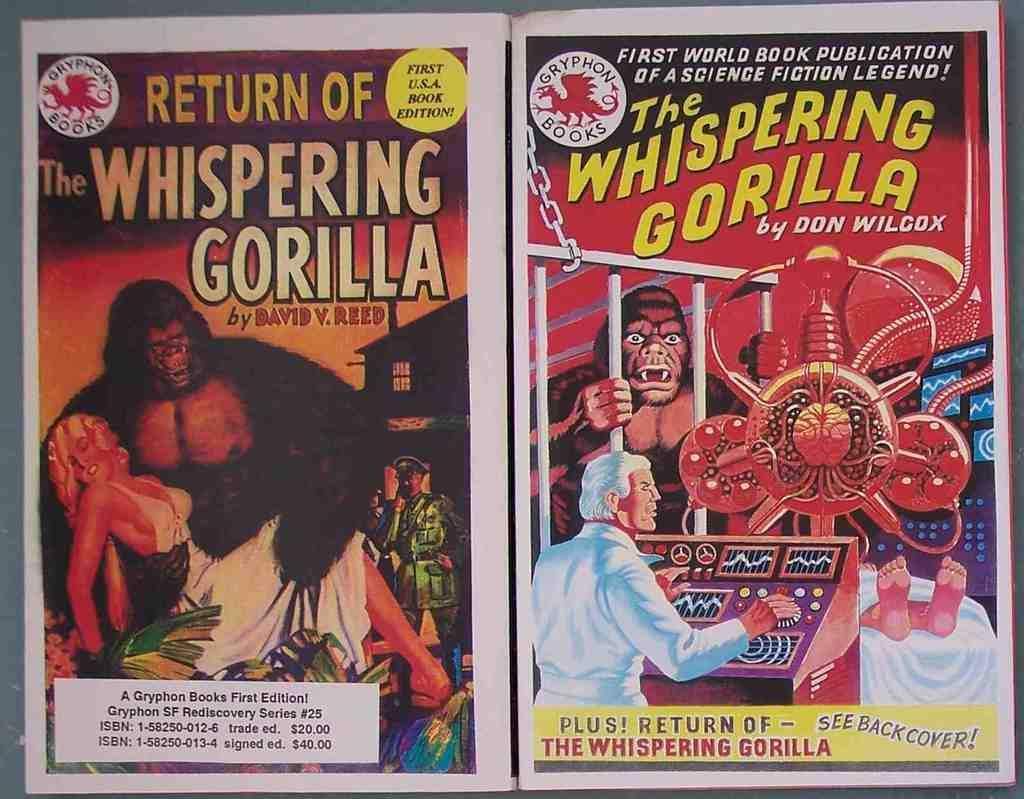Please provide a concise description of this image. As we can see in the image there are banners. On banners there are few people, gorillas and there is something written. 